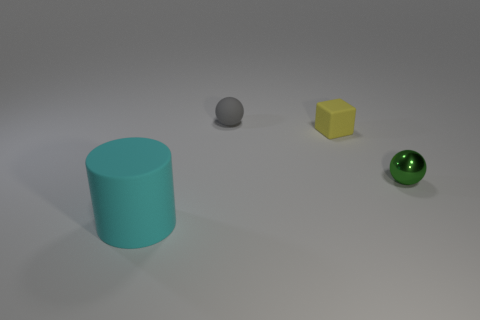There is a sphere that is on the right side of the gray object; does it have the same size as the object that is on the left side of the rubber ball?
Provide a short and direct response. No. How big is the sphere that is right of the small gray rubber sphere?
Your answer should be compact. Small. The metallic ball that is the same size as the cube is what color?
Your answer should be compact. Green. Do the yellow matte block and the gray object have the same size?
Offer a very short reply. Yes. What size is the rubber thing that is in front of the small gray matte ball and behind the large cyan object?
Your answer should be very brief. Small. How many metallic objects are either tiny blue balls or tiny yellow objects?
Offer a terse response. 0. Is the number of small metallic spheres on the right side of the small gray ball greater than the number of small rubber objects?
Provide a succinct answer. No. There is a object on the left side of the gray rubber object; what material is it?
Make the answer very short. Rubber. How many large cyan things are the same material as the small green sphere?
Give a very brief answer. 0. The tiny thing that is both in front of the rubber ball and left of the small green metallic ball has what shape?
Your answer should be very brief. Cube. 